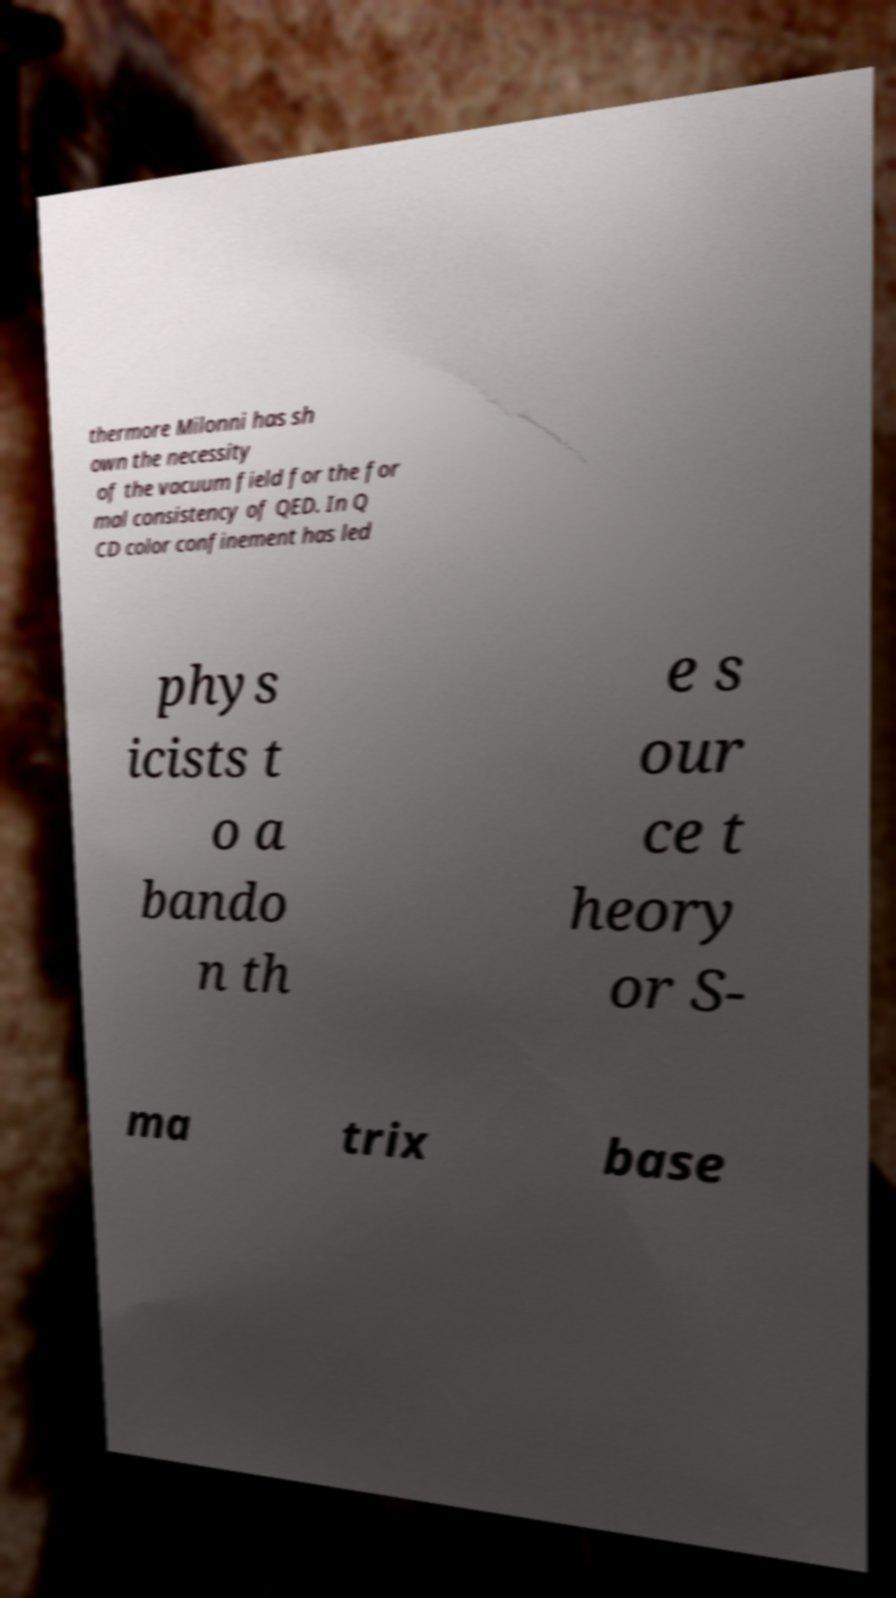I need the written content from this picture converted into text. Can you do that? thermore Milonni has sh own the necessity of the vacuum field for the for mal consistency of QED. In Q CD color confinement has led phys icists t o a bando n th e s our ce t heory or S- ma trix base 